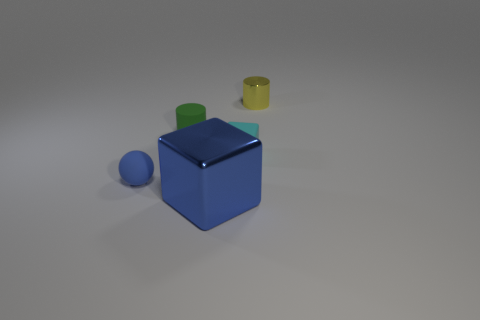Add 5 cylinders. How many objects exist? 10 Subtract all blocks. How many objects are left? 3 Add 1 yellow shiny objects. How many yellow shiny objects are left? 2 Add 2 large purple objects. How many large purple objects exist? 2 Subtract 0 green cubes. How many objects are left? 5 Subtract all cyan cubes. Subtract all shiny cylinders. How many objects are left? 3 